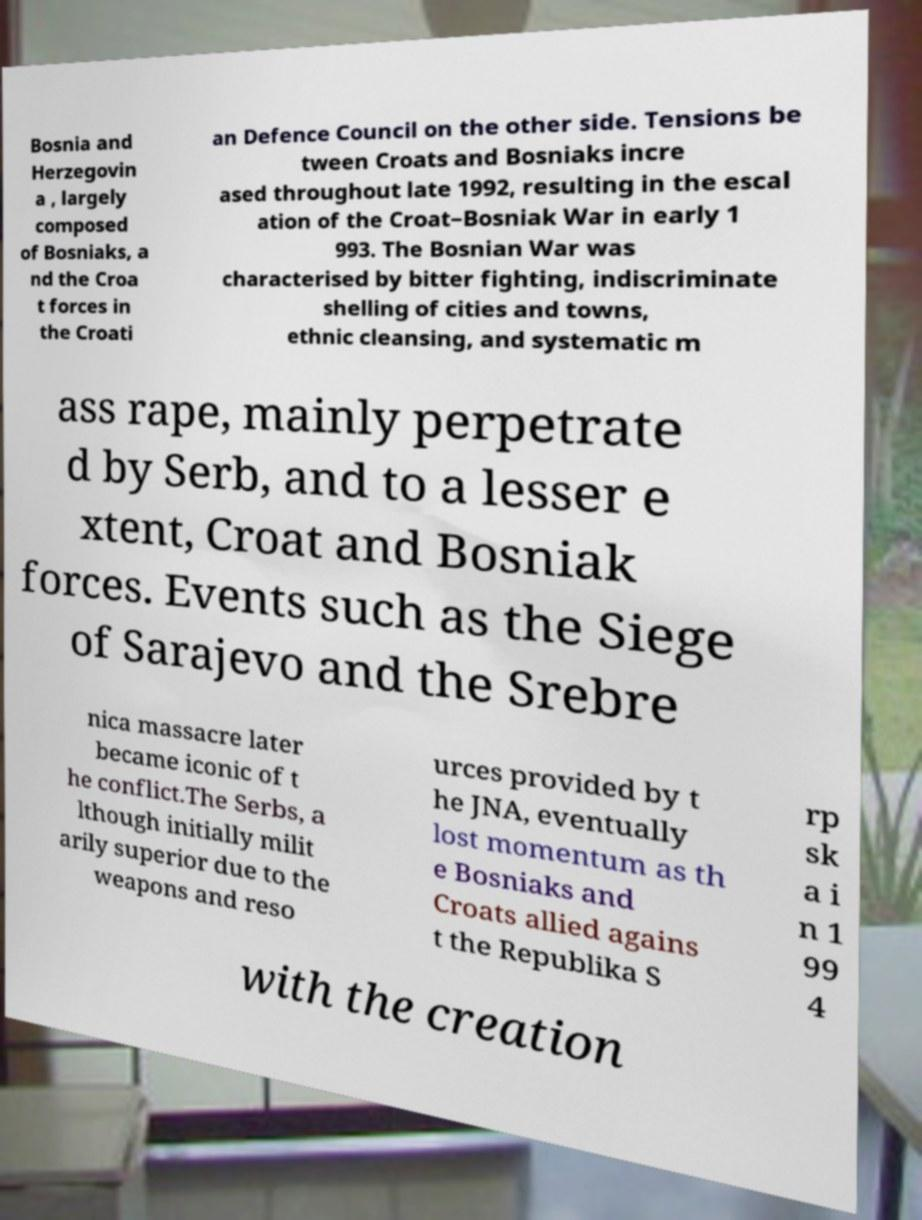I need the written content from this picture converted into text. Can you do that? Bosnia and Herzegovin a , largely composed of Bosniaks, a nd the Croa t forces in the Croati an Defence Council on the other side. Tensions be tween Croats and Bosniaks incre ased throughout late 1992, resulting in the escal ation of the Croat–Bosniak War in early 1 993. The Bosnian War was characterised by bitter fighting, indiscriminate shelling of cities and towns, ethnic cleansing, and systematic m ass rape, mainly perpetrate d by Serb, and to a lesser e xtent, Croat and Bosniak forces. Events such as the Siege of Sarajevo and the Srebre nica massacre later became iconic of t he conflict.The Serbs, a lthough initially milit arily superior due to the weapons and reso urces provided by t he JNA, eventually lost momentum as th e Bosniaks and Croats allied agains t the Republika S rp sk a i n 1 99 4 with the creation 